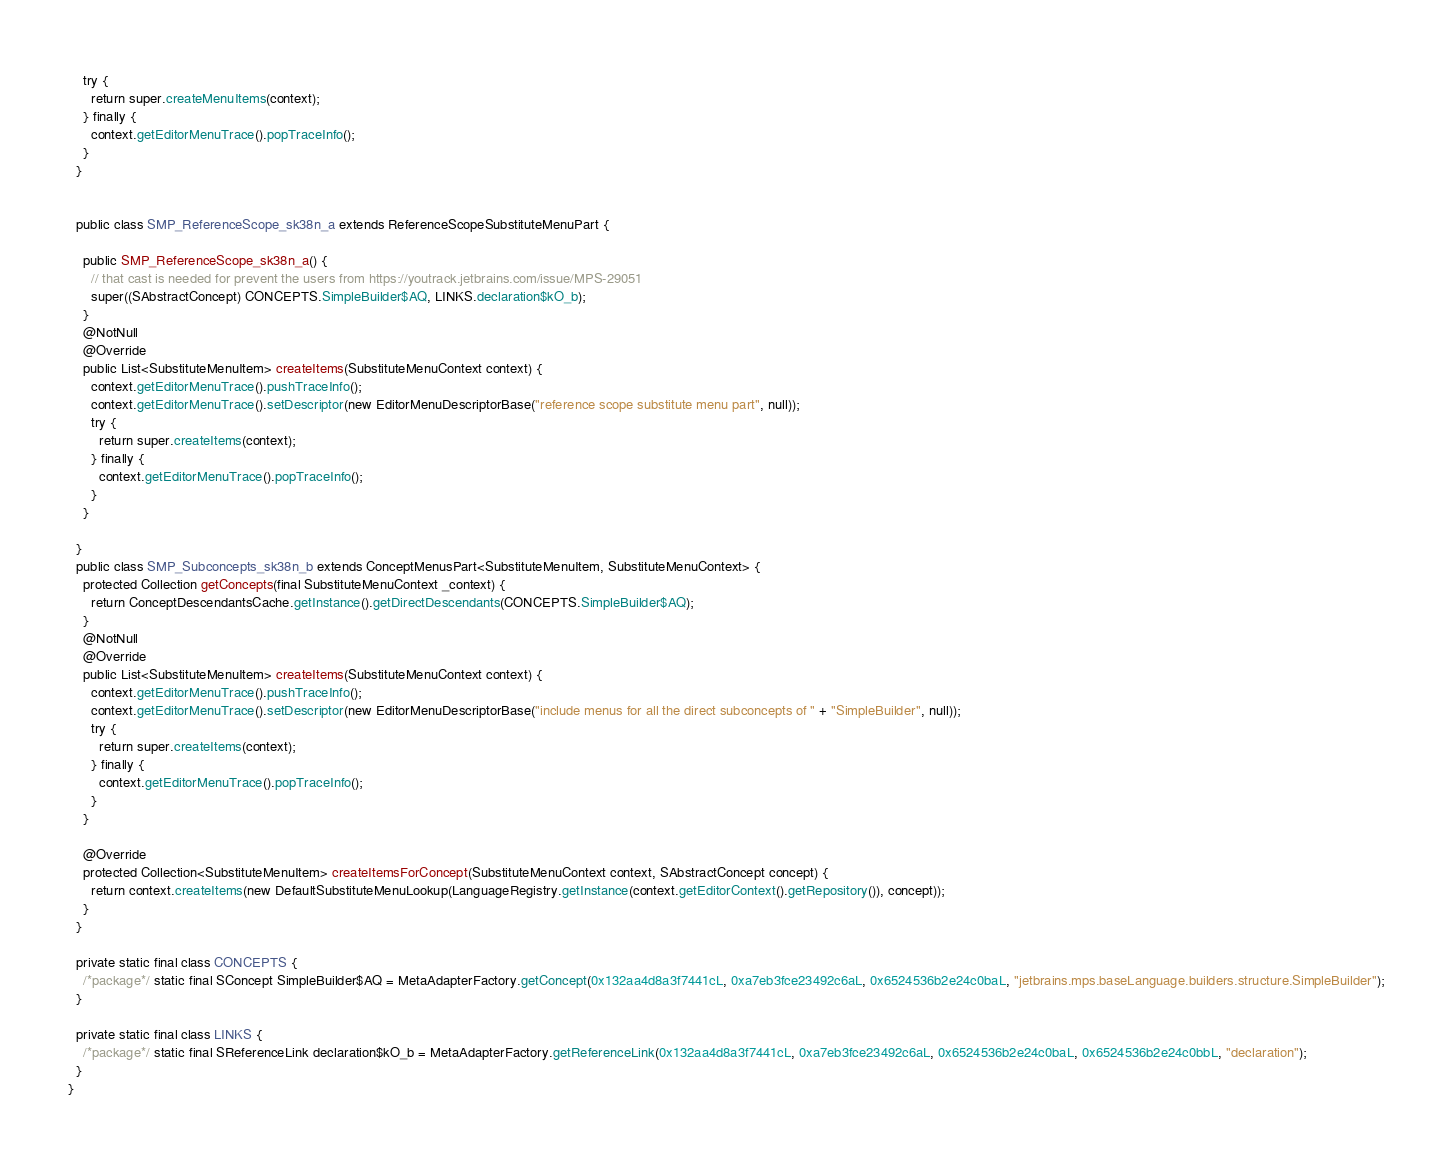<code> <loc_0><loc_0><loc_500><loc_500><_Java_>    try {
      return super.createMenuItems(context);
    } finally {
      context.getEditorMenuTrace().popTraceInfo();
    }
  }


  public class SMP_ReferenceScope_sk38n_a extends ReferenceScopeSubstituteMenuPart {

    public SMP_ReferenceScope_sk38n_a() {
      // that cast is needed for prevent the users from https://youtrack.jetbrains.com/issue/MPS-29051
      super((SAbstractConcept) CONCEPTS.SimpleBuilder$AQ, LINKS.declaration$kO_b);
    }
    @NotNull
    @Override
    public List<SubstituteMenuItem> createItems(SubstituteMenuContext context) {
      context.getEditorMenuTrace().pushTraceInfo();
      context.getEditorMenuTrace().setDescriptor(new EditorMenuDescriptorBase("reference scope substitute menu part", null));
      try {
        return super.createItems(context);
      } finally {
        context.getEditorMenuTrace().popTraceInfo();
      }
    }

  }
  public class SMP_Subconcepts_sk38n_b extends ConceptMenusPart<SubstituteMenuItem, SubstituteMenuContext> {
    protected Collection getConcepts(final SubstituteMenuContext _context) {
      return ConceptDescendantsCache.getInstance().getDirectDescendants(CONCEPTS.SimpleBuilder$AQ);
    }
    @NotNull
    @Override
    public List<SubstituteMenuItem> createItems(SubstituteMenuContext context) {
      context.getEditorMenuTrace().pushTraceInfo();
      context.getEditorMenuTrace().setDescriptor(new EditorMenuDescriptorBase("include menus for all the direct subconcepts of " + "SimpleBuilder", null));
      try {
        return super.createItems(context);
      } finally {
        context.getEditorMenuTrace().popTraceInfo();
      }
    }

    @Override
    protected Collection<SubstituteMenuItem> createItemsForConcept(SubstituteMenuContext context, SAbstractConcept concept) {
      return context.createItems(new DefaultSubstituteMenuLookup(LanguageRegistry.getInstance(context.getEditorContext().getRepository()), concept));
    }
  }

  private static final class CONCEPTS {
    /*package*/ static final SConcept SimpleBuilder$AQ = MetaAdapterFactory.getConcept(0x132aa4d8a3f7441cL, 0xa7eb3fce23492c6aL, 0x6524536b2e24c0baL, "jetbrains.mps.baseLanguage.builders.structure.SimpleBuilder");
  }

  private static final class LINKS {
    /*package*/ static final SReferenceLink declaration$kO_b = MetaAdapterFactory.getReferenceLink(0x132aa4d8a3f7441cL, 0xa7eb3fce23492c6aL, 0x6524536b2e24c0baL, 0x6524536b2e24c0bbL, "declaration");
  }
}
</code> 